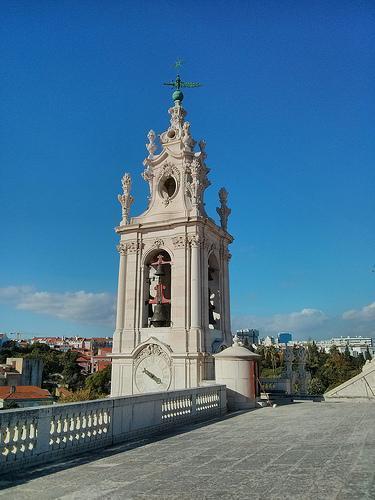How many bells are visible?
Give a very brief answer. 2. 